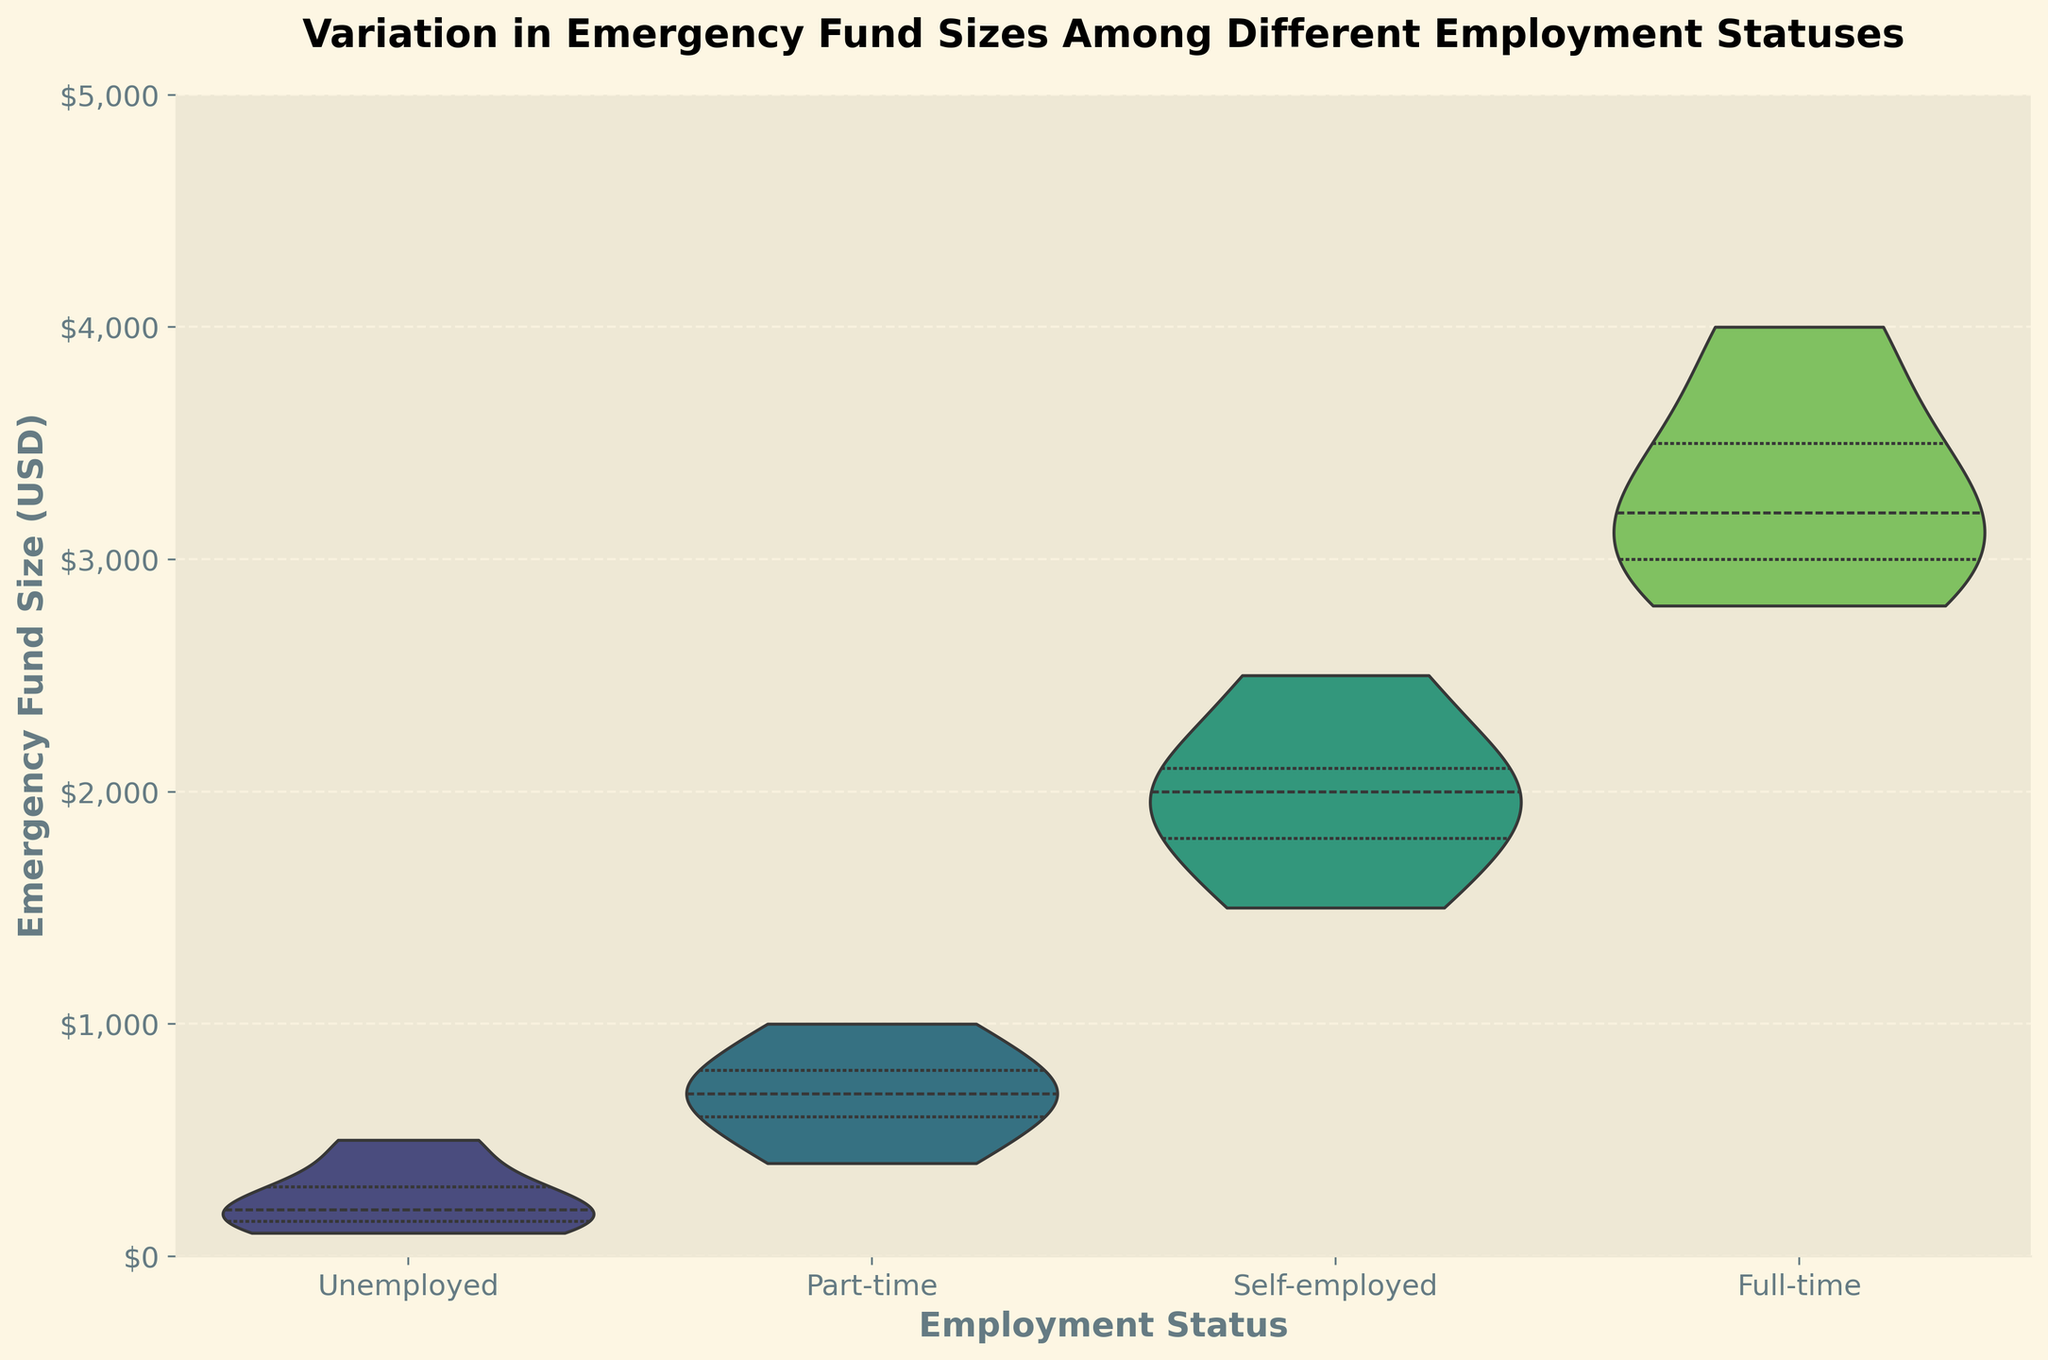What is the title of the figure? The title can be read directly from the top of the figure.
Answer: Variation in Emergency Fund Sizes Among Different Employment Statuses Which employment status appears to have the widest distribution of emergency fund sizes? This can be observed by looking at the width of the violin plots. The group with the widest plot has the most variation.
Answer: Full-time What is the median emergency fund size for the unemployed group? The median is indicated by a white dot within the violin plot for the unemployed group.
Answer: $200 How do the emergency fund sizes compare between part-time and self-employed individuals? Compare the central tendency (medians) and spread (quartiles and distribution) between the part-time and self-employed violin plots. Part-time has smaller medians and tighter distribution, self-employed has larger medians and wider distribution.
Answer: Self-employed has higher emergency funds Which employment status shows the highest emergency fund size, and what is that approximate value? The highest value can be seen at the top end of the violin plot for each group. The highest point overall is in the full-time group.
Answer: Full-time, approximately $4000 What can you infer about the emergency fund sizes for unemployed individuals compared to other groups? The violin plot for unemployed individuals is much narrower and lower in height compared to other groups, indicating smaller and less varied emergency funds.
Answer: Smaller and less varied What quartile range does the emergency fund size fall into for self-employed individuals? The quartile range can be estimated by the spread of the central white area within the self-employed violin plot.
Answer: Approximately $1800 to $2100 Is the emergency fund size for full-time workers mostly above or below $3000? Observing the violin plot for the full-time group, most of the distribution is above $3000.
Answer: Mostly above How does the distribution shape differ between the part-time and full-time employment statuses? Compare the overall shape and spread of the violin plots. Part-time has a narrower and more evenly distributed shape, whereas full-time has a wider base, indicating more variation in higher values.
Answer: Part-Time is narrower and more even, Full-Time is wider with more variation at higher values Which employment status has the smallest range of emergency fund sizes? The range can be seen directly from the height of the violin plot. The group with the shortest height has the smallest range.
Answer: Unemployed 